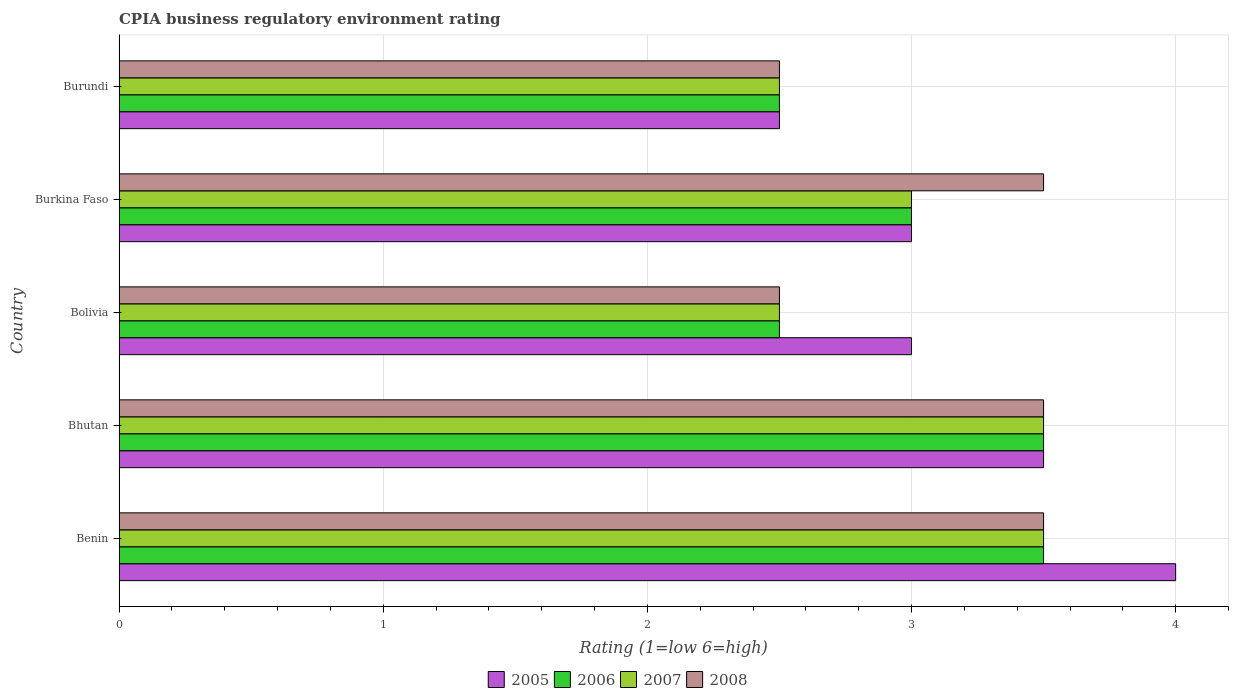How many groups of bars are there?
Your response must be concise. 5. How many bars are there on the 5th tick from the bottom?
Make the answer very short. 4. What is the label of the 2nd group of bars from the top?
Ensure brevity in your answer.  Burkina Faso. In how many cases, is the number of bars for a given country not equal to the number of legend labels?
Keep it short and to the point. 0. What is the CPIA rating in 2006 in Bolivia?
Provide a succinct answer. 2.5. In which country was the CPIA rating in 2005 maximum?
Provide a short and direct response. Benin. In which country was the CPIA rating in 2008 minimum?
Keep it short and to the point. Bolivia. What is the difference between the CPIA rating in 2006 in Bhutan and that in Burundi?
Your answer should be compact. 1. What is the difference between the CPIA rating in 2007 and CPIA rating in 2008 in Burundi?
Your answer should be very brief. 0. In how many countries, is the CPIA rating in 2007 greater than 2 ?
Your response must be concise. 5. What is the ratio of the CPIA rating in 2007 in Bhutan to that in Burundi?
Ensure brevity in your answer.  1.4. What is the difference between the highest and the lowest CPIA rating in 2006?
Ensure brevity in your answer.  1. What does the 3rd bar from the bottom in Burkina Faso represents?
Make the answer very short. 2007. How many bars are there?
Your answer should be compact. 20. Are all the bars in the graph horizontal?
Offer a terse response. Yes. What is the difference between two consecutive major ticks on the X-axis?
Offer a very short reply. 1. Does the graph contain any zero values?
Ensure brevity in your answer.  No. How many legend labels are there?
Offer a very short reply. 4. How are the legend labels stacked?
Your answer should be very brief. Horizontal. What is the title of the graph?
Make the answer very short. CPIA business regulatory environment rating. Does "1962" appear as one of the legend labels in the graph?
Keep it short and to the point. No. What is the label or title of the X-axis?
Give a very brief answer. Rating (1=low 6=high). What is the label or title of the Y-axis?
Keep it short and to the point. Country. What is the Rating (1=low 6=high) in 2005 in Bhutan?
Offer a very short reply. 3.5. What is the Rating (1=low 6=high) of 2006 in Bhutan?
Ensure brevity in your answer.  3.5. What is the Rating (1=low 6=high) in 2007 in Bhutan?
Keep it short and to the point. 3.5. What is the Rating (1=low 6=high) of 2008 in Bhutan?
Offer a very short reply. 3.5. What is the Rating (1=low 6=high) of 2007 in Bolivia?
Offer a very short reply. 2.5. What is the Rating (1=low 6=high) in 2005 in Burkina Faso?
Keep it short and to the point. 3. What is the Rating (1=low 6=high) in 2006 in Burkina Faso?
Your response must be concise. 3. What is the Rating (1=low 6=high) in 2007 in Burkina Faso?
Make the answer very short. 3. What is the Rating (1=low 6=high) of 2008 in Burkina Faso?
Give a very brief answer. 3.5. Across all countries, what is the minimum Rating (1=low 6=high) of 2005?
Ensure brevity in your answer.  2.5. Across all countries, what is the minimum Rating (1=low 6=high) in 2006?
Ensure brevity in your answer.  2.5. Across all countries, what is the minimum Rating (1=low 6=high) in 2008?
Offer a terse response. 2.5. What is the total Rating (1=low 6=high) of 2005 in the graph?
Offer a terse response. 16. What is the total Rating (1=low 6=high) of 2006 in the graph?
Make the answer very short. 15. What is the total Rating (1=low 6=high) in 2007 in the graph?
Provide a succinct answer. 15. What is the total Rating (1=low 6=high) in 2008 in the graph?
Keep it short and to the point. 15.5. What is the difference between the Rating (1=low 6=high) in 2006 in Benin and that in Bhutan?
Offer a very short reply. 0. What is the difference between the Rating (1=low 6=high) in 2007 in Benin and that in Bhutan?
Offer a terse response. 0. What is the difference between the Rating (1=low 6=high) of 2008 in Benin and that in Bhutan?
Your answer should be very brief. 0. What is the difference between the Rating (1=low 6=high) in 2005 in Benin and that in Bolivia?
Make the answer very short. 1. What is the difference between the Rating (1=low 6=high) of 2006 in Benin and that in Bolivia?
Make the answer very short. 1. What is the difference between the Rating (1=low 6=high) in 2007 in Benin and that in Burkina Faso?
Offer a very short reply. 0.5. What is the difference between the Rating (1=low 6=high) in 2005 in Benin and that in Burundi?
Your answer should be compact. 1.5. What is the difference between the Rating (1=low 6=high) of 2008 in Benin and that in Burundi?
Make the answer very short. 1. What is the difference between the Rating (1=low 6=high) of 2007 in Bhutan and that in Bolivia?
Your answer should be compact. 1. What is the difference between the Rating (1=low 6=high) in 2006 in Bhutan and that in Burkina Faso?
Your answer should be compact. 0.5. What is the difference between the Rating (1=low 6=high) of 2007 in Bhutan and that in Burkina Faso?
Keep it short and to the point. 0.5. What is the difference between the Rating (1=low 6=high) in 2005 in Bhutan and that in Burundi?
Provide a succinct answer. 1. What is the difference between the Rating (1=low 6=high) in 2006 in Bhutan and that in Burundi?
Your answer should be compact. 1. What is the difference between the Rating (1=low 6=high) of 2007 in Bhutan and that in Burundi?
Give a very brief answer. 1. What is the difference between the Rating (1=low 6=high) of 2006 in Bolivia and that in Burkina Faso?
Your answer should be very brief. -0.5. What is the difference between the Rating (1=low 6=high) of 2007 in Bolivia and that in Burkina Faso?
Offer a terse response. -0.5. What is the difference between the Rating (1=low 6=high) of 2008 in Bolivia and that in Burkina Faso?
Offer a very short reply. -1. What is the difference between the Rating (1=low 6=high) of 2005 in Bolivia and that in Burundi?
Keep it short and to the point. 0.5. What is the difference between the Rating (1=low 6=high) of 2007 in Bolivia and that in Burundi?
Offer a terse response. 0. What is the difference between the Rating (1=low 6=high) in 2008 in Bolivia and that in Burundi?
Your answer should be compact. 0. What is the difference between the Rating (1=low 6=high) of 2008 in Burkina Faso and that in Burundi?
Provide a short and direct response. 1. What is the difference between the Rating (1=low 6=high) in 2005 in Benin and the Rating (1=low 6=high) in 2008 in Bhutan?
Make the answer very short. 0.5. What is the difference between the Rating (1=low 6=high) in 2007 in Benin and the Rating (1=low 6=high) in 2008 in Bhutan?
Offer a very short reply. 0. What is the difference between the Rating (1=low 6=high) in 2006 in Benin and the Rating (1=low 6=high) in 2007 in Bolivia?
Provide a short and direct response. 1. What is the difference between the Rating (1=low 6=high) in 2006 in Benin and the Rating (1=low 6=high) in 2008 in Bolivia?
Make the answer very short. 1. What is the difference between the Rating (1=low 6=high) in 2007 in Benin and the Rating (1=low 6=high) in 2008 in Bolivia?
Provide a succinct answer. 1. What is the difference between the Rating (1=low 6=high) in 2005 in Benin and the Rating (1=low 6=high) in 2007 in Burkina Faso?
Provide a succinct answer. 1. What is the difference between the Rating (1=low 6=high) in 2005 in Benin and the Rating (1=low 6=high) in 2006 in Burundi?
Give a very brief answer. 1.5. What is the difference between the Rating (1=low 6=high) in 2006 in Benin and the Rating (1=low 6=high) in 2007 in Burundi?
Make the answer very short. 1. What is the difference between the Rating (1=low 6=high) of 2006 in Bhutan and the Rating (1=low 6=high) of 2007 in Bolivia?
Keep it short and to the point. 1. What is the difference between the Rating (1=low 6=high) of 2006 in Bhutan and the Rating (1=low 6=high) of 2008 in Bolivia?
Offer a very short reply. 1. What is the difference between the Rating (1=low 6=high) of 2007 in Bhutan and the Rating (1=low 6=high) of 2008 in Bolivia?
Your response must be concise. 1. What is the difference between the Rating (1=low 6=high) of 2005 in Bhutan and the Rating (1=low 6=high) of 2007 in Burkina Faso?
Offer a terse response. 0.5. What is the difference between the Rating (1=low 6=high) in 2005 in Bhutan and the Rating (1=low 6=high) in 2008 in Burkina Faso?
Provide a short and direct response. 0. What is the difference between the Rating (1=low 6=high) of 2006 in Bhutan and the Rating (1=low 6=high) of 2007 in Burkina Faso?
Provide a succinct answer. 0.5. What is the difference between the Rating (1=low 6=high) of 2007 in Bhutan and the Rating (1=low 6=high) of 2008 in Burkina Faso?
Offer a very short reply. 0. What is the difference between the Rating (1=low 6=high) in 2005 in Bhutan and the Rating (1=low 6=high) in 2006 in Burundi?
Ensure brevity in your answer.  1. What is the difference between the Rating (1=low 6=high) of 2005 in Bhutan and the Rating (1=low 6=high) of 2007 in Burundi?
Provide a succinct answer. 1. What is the difference between the Rating (1=low 6=high) of 2006 in Bhutan and the Rating (1=low 6=high) of 2008 in Burundi?
Give a very brief answer. 1. What is the difference between the Rating (1=low 6=high) in 2005 in Bolivia and the Rating (1=low 6=high) in 2007 in Burkina Faso?
Keep it short and to the point. 0. What is the difference between the Rating (1=low 6=high) of 2006 in Bolivia and the Rating (1=low 6=high) of 2007 in Burkina Faso?
Provide a short and direct response. -0.5. What is the difference between the Rating (1=low 6=high) of 2007 in Bolivia and the Rating (1=low 6=high) of 2008 in Burkina Faso?
Offer a very short reply. -1. What is the difference between the Rating (1=low 6=high) in 2005 in Bolivia and the Rating (1=low 6=high) in 2007 in Burundi?
Offer a very short reply. 0.5. What is the difference between the Rating (1=low 6=high) of 2006 in Bolivia and the Rating (1=low 6=high) of 2007 in Burundi?
Keep it short and to the point. 0. What is the difference between the Rating (1=low 6=high) of 2007 in Bolivia and the Rating (1=low 6=high) of 2008 in Burundi?
Make the answer very short. 0. What is the difference between the Rating (1=low 6=high) of 2006 in Burkina Faso and the Rating (1=low 6=high) of 2007 in Burundi?
Provide a succinct answer. 0.5. What is the difference between the Rating (1=low 6=high) of 2006 in Burkina Faso and the Rating (1=low 6=high) of 2008 in Burundi?
Your answer should be very brief. 0.5. What is the average Rating (1=low 6=high) of 2006 per country?
Provide a succinct answer. 3. What is the average Rating (1=low 6=high) in 2007 per country?
Make the answer very short. 3. What is the difference between the Rating (1=low 6=high) of 2005 and Rating (1=low 6=high) of 2008 in Benin?
Offer a terse response. 0.5. What is the difference between the Rating (1=low 6=high) of 2006 and Rating (1=low 6=high) of 2007 in Benin?
Your response must be concise. 0. What is the difference between the Rating (1=low 6=high) in 2005 and Rating (1=low 6=high) in 2006 in Bhutan?
Keep it short and to the point. 0. What is the difference between the Rating (1=low 6=high) of 2005 and Rating (1=low 6=high) of 2008 in Bhutan?
Provide a succinct answer. 0. What is the difference between the Rating (1=low 6=high) in 2006 and Rating (1=low 6=high) in 2007 in Bhutan?
Offer a very short reply. 0. What is the difference between the Rating (1=low 6=high) of 2005 and Rating (1=low 6=high) of 2006 in Bolivia?
Offer a very short reply. 0.5. What is the difference between the Rating (1=low 6=high) of 2006 and Rating (1=low 6=high) of 2007 in Bolivia?
Make the answer very short. 0. What is the difference between the Rating (1=low 6=high) in 2006 and Rating (1=low 6=high) in 2008 in Bolivia?
Offer a terse response. 0. What is the difference between the Rating (1=low 6=high) of 2007 and Rating (1=low 6=high) of 2008 in Bolivia?
Ensure brevity in your answer.  0. What is the difference between the Rating (1=low 6=high) of 2005 and Rating (1=low 6=high) of 2006 in Burkina Faso?
Offer a terse response. 0. What is the difference between the Rating (1=low 6=high) of 2006 and Rating (1=low 6=high) of 2007 in Burkina Faso?
Your answer should be compact. 0. What is the difference between the Rating (1=low 6=high) in 2006 and Rating (1=low 6=high) in 2008 in Burkina Faso?
Your answer should be compact. -0.5. What is the difference between the Rating (1=low 6=high) of 2007 and Rating (1=low 6=high) of 2008 in Burkina Faso?
Provide a succinct answer. -0.5. What is the difference between the Rating (1=low 6=high) of 2005 and Rating (1=low 6=high) of 2006 in Burundi?
Offer a very short reply. 0. What is the difference between the Rating (1=low 6=high) of 2005 and Rating (1=low 6=high) of 2007 in Burundi?
Make the answer very short. 0. What is the difference between the Rating (1=low 6=high) of 2007 and Rating (1=low 6=high) of 2008 in Burundi?
Your answer should be compact. 0. What is the ratio of the Rating (1=low 6=high) of 2006 in Benin to that in Bolivia?
Keep it short and to the point. 1.4. What is the ratio of the Rating (1=low 6=high) in 2007 in Benin to that in Bolivia?
Offer a terse response. 1.4. What is the ratio of the Rating (1=low 6=high) of 2005 in Benin to that in Burkina Faso?
Make the answer very short. 1.33. What is the ratio of the Rating (1=low 6=high) of 2006 in Benin to that in Burkina Faso?
Make the answer very short. 1.17. What is the ratio of the Rating (1=low 6=high) in 2007 in Benin to that in Burkina Faso?
Keep it short and to the point. 1.17. What is the ratio of the Rating (1=low 6=high) in 2006 in Benin to that in Burundi?
Give a very brief answer. 1.4. What is the ratio of the Rating (1=low 6=high) of 2008 in Benin to that in Burundi?
Provide a short and direct response. 1.4. What is the ratio of the Rating (1=low 6=high) of 2005 in Bhutan to that in Bolivia?
Make the answer very short. 1.17. What is the ratio of the Rating (1=low 6=high) in 2006 in Bhutan to that in Bolivia?
Your answer should be very brief. 1.4. What is the ratio of the Rating (1=low 6=high) in 2005 in Bhutan to that in Burkina Faso?
Your response must be concise. 1.17. What is the ratio of the Rating (1=low 6=high) in 2005 in Bhutan to that in Burundi?
Give a very brief answer. 1.4. What is the ratio of the Rating (1=low 6=high) in 2006 in Bhutan to that in Burundi?
Provide a succinct answer. 1.4. What is the ratio of the Rating (1=low 6=high) of 2006 in Bolivia to that in Burkina Faso?
Give a very brief answer. 0.83. What is the ratio of the Rating (1=low 6=high) in 2005 in Bolivia to that in Burundi?
Make the answer very short. 1.2. What is the ratio of the Rating (1=low 6=high) in 2006 in Bolivia to that in Burundi?
Your answer should be compact. 1. What is the ratio of the Rating (1=low 6=high) in 2008 in Bolivia to that in Burundi?
Provide a short and direct response. 1. What is the ratio of the Rating (1=low 6=high) of 2005 in Burkina Faso to that in Burundi?
Ensure brevity in your answer.  1.2. What is the ratio of the Rating (1=low 6=high) in 2007 in Burkina Faso to that in Burundi?
Make the answer very short. 1.2. What is the difference between the highest and the second highest Rating (1=low 6=high) in 2007?
Keep it short and to the point. 0. What is the difference between the highest and the lowest Rating (1=low 6=high) in 2005?
Offer a very short reply. 1.5. What is the difference between the highest and the lowest Rating (1=low 6=high) in 2006?
Keep it short and to the point. 1. 